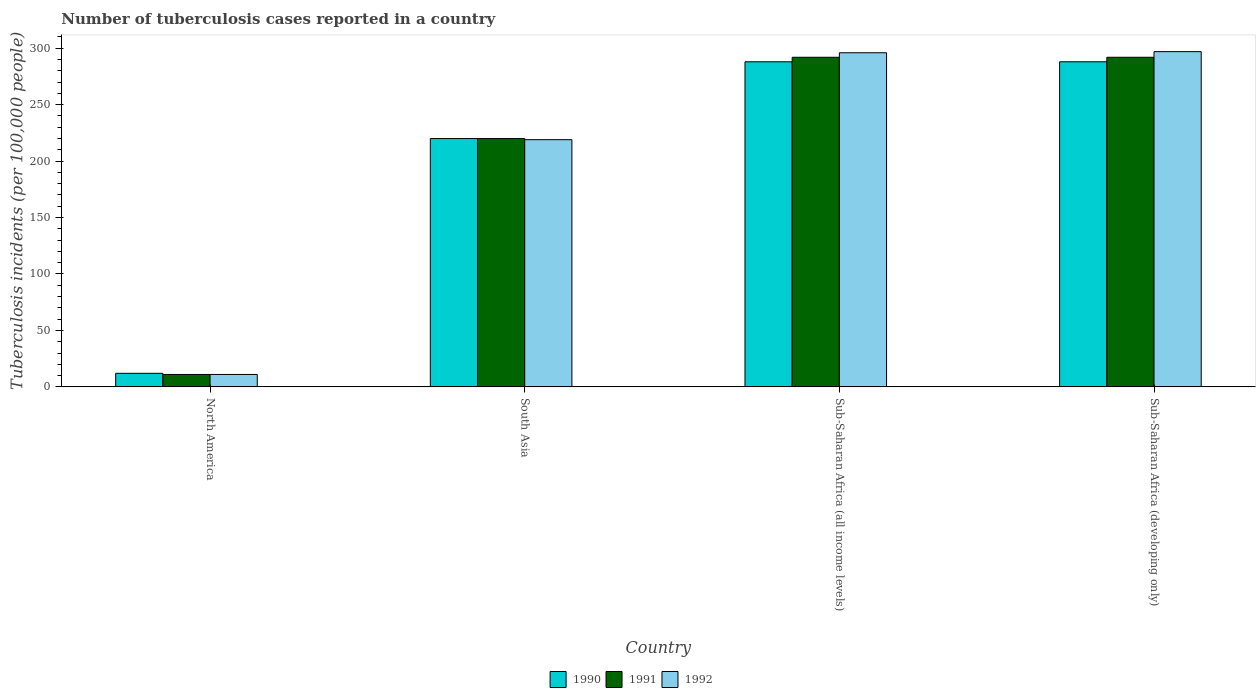How many different coloured bars are there?
Keep it short and to the point. 3. Are the number of bars per tick equal to the number of legend labels?
Keep it short and to the point. Yes. How many bars are there on the 2nd tick from the left?
Make the answer very short. 3. How many bars are there on the 1st tick from the right?
Provide a succinct answer. 3. What is the label of the 1st group of bars from the left?
Provide a short and direct response. North America. In how many cases, is the number of bars for a given country not equal to the number of legend labels?
Offer a very short reply. 0. What is the number of tuberculosis cases reported in in 1990 in Sub-Saharan Africa (developing only)?
Make the answer very short. 288. Across all countries, what is the maximum number of tuberculosis cases reported in in 1990?
Ensure brevity in your answer.  288. Across all countries, what is the minimum number of tuberculosis cases reported in in 1992?
Offer a very short reply. 11. In which country was the number of tuberculosis cases reported in in 1990 maximum?
Offer a very short reply. Sub-Saharan Africa (all income levels). In which country was the number of tuberculosis cases reported in in 1991 minimum?
Provide a short and direct response. North America. What is the total number of tuberculosis cases reported in in 1991 in the graph?
Provide a short and direct response. 815. What is the difference between the number of tuberculosis cases reported in in 1992 in North America and that in Sub-Saharan Africa (developing only)?
Offer a terse response. -286. What is the difference between the number of tuberculosis cases reported in in 1991 in Sub-Saharan Africa (developing only) and the number of tuberculosis cases reported in in 1992 in North America?
Provide a short and direct response. 281. What is the average number of tuberculosis cases reported in in 1992 per country?
Provide a short and direct response. 205.75. What is the difference between the number of tuberculosis cases reported in of/in 1992 and number of tuberculosis cases reported in of/in 1991 in Sub-Saharan Africa (all income levels)?
Offer a very short reply. 4. What is the ratio of the number of tuberculosis cases reported in in 1990 in North America to that in South Asia?
Your answer should be very brief. 0.05. Is the difference between the number of tuberculosis cases reported in in 1992 in South Asia and Sub-Saharan Africa (all income levels) greater than the difference between the number of tuberculosis cases reported in in 1991 in South Asia and Sub-Saharan Africa (all income levels)?
Make the answer very short. No. What is the difference between the highest and the lowest number of tuberculosis cases reported in in 1990?
Your answer should be very brief. 276. In how many countries, is the number of tuberculosis cases reported in in 1990 greater than the average number of tuberculosis cases reported in in 1990 taken over all countries?
Your answer should be compact. 3. Is the sum of the number of tuberculosis cases reported in in 1992 in South Asia and Sub-Saharan Africa (developing only) greater than the maximum number of tuberculosis cases reported in in 1990 across all countries?
Your answer should be very brief. Yes. What does the 1st bar from the right in Sub-Saharan Africa (developing only) represents?
Keep it short and to the point. 1992. How many bars are there?
Keep it short and to the point. 12. Are all the bars in the graph horizontal?
Your answer should be compact. No. How many countries are there in the graph?
Offer a terse response. 4. What is the difference between two consecutive major ticks on the Y-axis?
Your answer should be very brief. 50. How many legend labels are there?
Provide a succinct answer. 3. How are the legend labels stacked?
Offer a very short reply. Horizontal. What is the title of the graph?
Your answer should be compact. Number of tuberculosis cases reported in a country. Does "1993" appear as one of the legend labels in the graph?
Your response must be concise. No. What is the label or title of the Y-axis?
Your answer should be compact. Tuberculosis incidents (per 100,0 people). What is the Tuberculosis incidents (per 100,000 people) in 1990 in North America?
Provide a succinct answer. 12. What is the Tuberculosis incidents (per 100,000 people) in 1992 in North America?
Ensure brevity in your answer.  11. What is the Tuberculosis incidents (per 100,000 people) in 1990 in South Asia?
Your response must be concise. 220. What is the Tuberculosis incidents (per 100,000 people) in 1991 in South Asia?
Make the answer very short. 220. What is the Tuberculosis incidents (per 100,000 people) in 1992 in South Asia?
Ensure brevity in your answer.  219. What is the Tuberculosis incidents (per 100,000 people) of 1990 in Sub-Saharan Africa (all income levels)?
Keep it short and to the point. 288. What is the Tuberculosis incidents (per 100,000 people) in 1991 in Sub-Saharan Africa (all income levels)?
Give a very brief answer. 292. What is the Tuberculosis incidents (per 100,000 people) of 1992 in Sub-Saharan Africa (all income levels)?
Keep it short and to the point. 296. What is the Tuberculosis incidents (per 100,000 people) in 1990 in Sub-Saharan Africa (developing only)?
Your answer should be compact. 288. What is the Tuberculosis incidents (per 100,000 people) of 1991 in Sub-Saharan Africa (developing only)?
Give a very brief answer. 292. What is the Tuberculosis incidents (per 100,000 people) in 1992 in Sub-Saharan Africa (developing only)?
Offer a terse response. 297. Across all countries, what is the maximum Tuberculosis incidents (per 100,000 people) of 1990?
Offer a very short reply. 288. Across all countries, what is the maximum Tuberculosis incidents (per 100,000 people) of 1991?
Offer a very short reply. 292. Across all countries, what is the maximum Tuberculosis incidents (per 100,000 people) in 1992?
Ensure brevity in your answer.  297. Across all countries, what is the minimum Tuberculosis incidents (per 100,000 people) in 1990?
Provide a succinct answer. 12. What is the total Tuberculosis incidents (per 100,000 people) of 1990 in the graph?
Provide a succinct answer. 808. What is the total Tuberculosis incidents (per 100,000 people) of 1991 in the graph?
Make the answer very short. 815. What is the total Tuberculosis incidents (per 100,000 people) of 1992 in the graph?
Provide a short and direct response. 823. What is the difference between the Tuberculosis incidents (per 100,000 people) of 1990 in North America and that in South Asia?
Offer a terse response. -208. What is the difference between the Tuberculosis incidents (per 100,000 people) of 1991 in North America and that in South Asia?
Your answer should be very brief. -209. What is the difference between the Tuberculosis incidents (per 100,000 people) of 1992 in North America and that in South Asia?
Provide a short and direct response. -208. What is the difference between the Tuberculosis incidents (per 100,000 people) of 1990 in North America and that in Sub-Saharan Africa (all income levels)?
Offer a very short reply. -276. What is the difference between the Tuberculosis incidents (per 100,000 people) in 1991 in North America and that in Sub-Saharan Africa (all income levels)?
Offer a terse response. -281. What is the difference between the Tuberculosis incidents (per 100,000 people) of 1992 in North America and that in Sub-Saharan Africa (all income levels)?
Your answer should be compact. -285. What is the difference between the Tuberculosis incidents (per 100,000 people) in 1990 in North America and that in Sub-Saharan Africa (developing only)?
Your response must be concise. -276. What is the difference between the Tuberculosis incidents (per 100,000 people) of 1991 in North America and that in Sub-Saharan Africa (developing only)?
Your answer should be very brief. -281. What is the difference between the Tuberculosis incidents (per 100,000 people) in 1992 in North America and that in Sub-Saharan Africa (developing only)?
Offer a terse response. -286. What is the difference between the Tuberculosis incidents (per 100,000 people) in 1990 in South Asia and that in Sub-Saharan Africa (all income levels)?
Your answer should be very brief. -68. What is the difference between the Tuberculosis incidents (per 100,000 people) of 1991 in South Asia and that in Sub-Saharan Africa (all income levels)?
Provide a short and direct response. -72. What is the difference between the Tuberculosis incidents (per 100,000 people) of 1992 in South Asia and that in Sub-Saharan Africa (all income levels)?
Provide a short and direct response. -77. What is the difference between the Tuberculosis incidents (per 100,000 people) in 1990 in South Asia and that in Sub-Saharan Africa (developing only)?
Provide a short and direct response. -68. What is the difference between the Tuberculosis incidents (per 100,000 people) in 1991 in South Asia and that in Sub-Saharan Africa (developing only)?
Make the answer very short. -72. What is the difference between the Tuberculosis incidents (per 100,000 people) in 1992 in South Asia and that in Sub-Saharan Africa (developing only)?
Ensure brevity in your answer.  -78. What is the difference between the Tuberculosis incidents (per 100,000 people) of 1990 in Sub-Saharan Africa (all income levels) and that in Sub-Saharan Africa (developing only)?
Your answer should be compact. 0. What is the difference between the Tuberculosis incidents (per 100,000 people) of 1991 in Sub-Saharan Africa (all income levels) and that in Sub-Saharan Africa (developing only)?
Offer a very short reply. 0. What is the difference between the Tuberculosis incidents (per 100,000 people) of 1992 in Sub-Saharan Africa (all income levels) and that in Sub-Saharan Africa (developing only)?
Your answer should be very brief. -1. What is the difference between the Tuberculosis incidents (per 100,000 people) of 1990 in North America and the Tuberculosis incidents (per 100,000 people) of 1991 in South Asia?
Make the answer very short. -208. What is the difference between the Tuberculosis incidents (per 100,000 people) in 1990 in North America and the Tuberculosis incidents (per 100,000 people) in 1992 in South Asia?
Give a very brief answer. -207. What is the difference between the Tuberculosis incidents (per 100,000 people) of 1991 in North America and the Tuberculosis incidents (per 100,000 people) of 1992 in South Asia?
Your answer should be very brief. -208. What is the difference between the Tuberculosis incidents (per 100,000 people) of 1990 in North America and the Tuberculosis incidents (per 100,000 people) of 1991 in Sub-Saharan Africa (all income levels)?
Your response must be concise. -280. What is the difference between the Tuberculosis incidents (per 100,000 people) in 1990 in North America and the Tuberculosis incidents (per 100,000 people) in 1992 in Sub-Saharan Africa (all income levels)?
Your response must be concise. -284. What is the difference between the Tuberculosis incidents (per 100,000 people) in 1991 in North America and the Tuberculosis incidents (per 100,000 people) in 1992 in Sub-Saharan Africa (all income levels)?
Ensure brevity in your answer.  -285. What is the difference between the Tuberculosis incidents (per 100,000 people) of 1990 in North America and the Tuberculosis incidents (per 100,000 people) of 1991 in Sub-Saharan Africa (developing only)?
Ensure brevity in your answer.  -280. What is the difference between the Tuberculosis incidents (per 100,000 people) in 1990 in North America and the Tuberculosis incidents (per 100,000 people) in 1992 in Sub-Saharan Africa (developing only)?
Your response must be concise. -285. What is the difference between the Tuberculosis incidents (per 100,000 people) of 1991 in North America and the Tuberculosis incidents (per 100,000 people) of 1992 in Sub-Saharan Africa (developing only)?
Make the answer very short. -286. What is the difference between the Tuberculosis incidents (per 100,000 people) in 1990 in South Asia and the Tuberculosis incidents (per 100,000 people) in 1991 in Sub-Saharan Africa (all income levels)?
Give a very brief answer. -72. What is the difference between the Tuberculosis incidents (per 100,000 people) in 1990 in South Asia and the Tuberculosis incidents (per 100,000 people) in 1992 in Sub-Saharan Africa (all income levels)?
Offer a very short reply. -76. What is the difference between the Tuberculosis incidents (per 100,000 people) of 1991 in South Asia and the Tuberculosis incidents (per 100,000 people) of 1992 in Sub-Saharan Africa (all income levels)?
Provide a short and direct response. -76. What is the difference between the Tuberculosis incidents (per 100,000 people) in 1990 in South Asia and the Tuberculosis incidents (per 100,000 people) in 1991 in Sub-Saharan Africa (developing only)?
Provide a succinct answer. -72. What is the difference between the Tuberculosis incidents (per 100,000 people) in 1990 in South Asia and the Tuberculosis incidents (per 100,000 people) in 1992 in Sub-Saharan Africa (developing only)?
Offer a very short reply. -77. What is the difference between the Tuberculosis incidents (per 100,000 people) of 1991 in South Asia and the Tuberculosis incidents (per 100,000 people) of 1992 in Sub-Saharan Africa (developing only)?
Keep it short and to the point. -77. What is the difference between the Tuberculosis incidents (per 100,000 people) of 1990 in Sub-Saharan Africa (all income levels) and the Tuberculosis incidents (per 100,000 people) of 1992 in Sub-Saharan Africa (developing only)?
Make the answer very short. -9. What is the average Tuberculosis incidents (per 100,000 people) of 1990 per country?
Make the answer very short. 202. What is the average Tuberculosis incidents (per 100,000 people) in 1991 per country?
Ensure brevity in your answer.  203.75. What is the average Tuberculosis incidents (per 100,000 people) of 1992 per country?
Provide a succinct answer. 205.75. What is the difference between the Tuberculosis incidents (per 100,000 people) in 1991 and Tuberculosis incidents (per 100,000 people) in 1992 in North America?
Your answer should be very brief. 0. What is the difference between the Tuberculosis incidents (per 100,000 people) of 1990 and Tuberculosis incidents (per 100,000 people) of 1991 in South Asia?
Ensure brevity in your answer.  0. What is the difference between the Tuberculosis incidents (per 100,000 people) of 1990 and Tuberculosis incidents (per 100,000 people) of 1992 in Sub-Saharan Africa (all income levels)?
Your answer should be very brief. -8. What is the difference between the Tuberculosis incidents (per 100,000 people) of 1991 and Tuberculosis incidents (per 100,000 people) of 1992 in Sub-Saharan Africa (all income levels)?
Make the answer very short. -4. What is the difference between the Tuberculosis incidents (per 100,000 people) in 1990 and Tuberculosis incidents (per 100,000 people) in 1991 in Sub-Saharan Africa (developing only)?
Provide a short and direct response. -4. What is the difference between the Tuberculosis incidents (per 100,000 people) in 1990 and Tuberculosis incidents (per 100,000 people) in 1992 in Sub-Saharan Africa (developing only)?
Provide a succinct answer. -9. What is the ratio of the Tuberculosis incidents (per 100,000 people) of 1990 in North America to that in South Asia?
Keep it short and to the point. 0.05. What is the ratio of the Tuberculosis incidents (per 100,000 people) in 1991 in North America to that in South Asia?
Your answer should be compact. 0.05. What is the ratio of the Tuberculosis incidents (per 100,000 people) of 1992 in North America to that in South Asia?
Ensure brevity in your answer.  0.05. What is the ratio of the Tuberculosis incidents (per 100,000 people) of 1990 in North America to that in Sub-Saharan Africa (all income levels)?
Your answer should be very brief. 0.04. What is the ratio of the Tuberculosis incidents (per 100,000 people) in 1991 in North America to that in Sub-Saharan Africa (all income levels)?
Keep it short and to the point. 0.04. What is the ratio of the Tuberculosis incidents (per 100,000 people) in 1992 in North America to that in Sub-Saharan Africa (all income levels)?
Offer a very short reply. 0.04. What is the ratio of the Tuberculosis incidents (per 100,000 people) of 1990 in North America to that in Sub-Saharan Africa (developing only)?
Give a very brief answer. 0.04. What is the ratio of the Tuberculosis incidents (per 100,000 people) of 1991 in North America to that in Sub-Saharan Africa (developing only)?
Your response must be concise. 0.04. What is the ratio of the Tuberculosis incidents (per 100,000 people) in 1992 in North America to that in Sub-Saharan Africa (developing only)?
Make the answer very short. 0.04. What is the ratio of the Tuberculosis incidents (per 100,000 people) of 1990 in South Asia to that in Sub-Saharan Africa (all income levels)?
Provide a short and direct response. 0.76. What is the ratio of the Tuberculosis incidents (per 100,000 people) in 1991 in South Asia to that in Sub-Saharan Africa (all income levels)?
Your answer should be compact. 0.75. What is the ratio of the Tuberculosis incidents (per 100,000 people) of 1992 in South Asia to that in Sub-Saharan Africa (all income levels)?
Give a very brief answer. 0.74. What is the ratio of the Tuberculosis incidents (per 100,000 people) in 1990 in South Asia to that in Sub-Saharan Africa (developing only)?
Offer a very short reply. 0.76. What is the ratio of the Tuberculosis incidents (per 100,000 people) in 1991 in South Asia to that in Sub-Saharan Africa (developing only)?
Your answer should be compact. 0.75. What is the ratio of the Tuberculosis incidents (per 100,000 people) of 1992 in South Asia to that in Sub-Saharan Africa (developing only)?
Your response must be concise. 0.74. What is the ratio of the Tuberculosis incidents (per 100,000 people) in 1990 in Sub-Saharan Africa (all income levels) to that in Sub-Saharan Africa (developing only)?
Give a very brief answer. 1. What is the ratio of the Tuberculosis incidents (per 100,000 people) of 1991 in Sub-Saharan Africa (all income levels) to that in Sub-Saharan Africa (developing only)?
Your answer should be very brief. 1. What is the ratio of the Tuberculosis incidents (per 100,000 people) of 1992 in Sub-Saharan Africa (all income levels) to that in Sub-Saharan Africa (developing only)?
Provide a succinct answer. 1. What is the difference between the highest and the second highest Tuberculosis incidents (per 100,000 people) in 1990?
Offer a terse response. 0. What is the difference between the highest and the lowest Tuberculosis incidents (per 100,000 people) in 1990?
Your answer should be very brief. 276. What is the difference between the highest and the lowest Tuberculosis incidents (per 100,000 people) in 1991?
Your response must be concise. 281. What is the difference between the highest and the lowest Tuberculosis incidents (per 100,000 people) of 1992?
Your response must be concise. 286. 